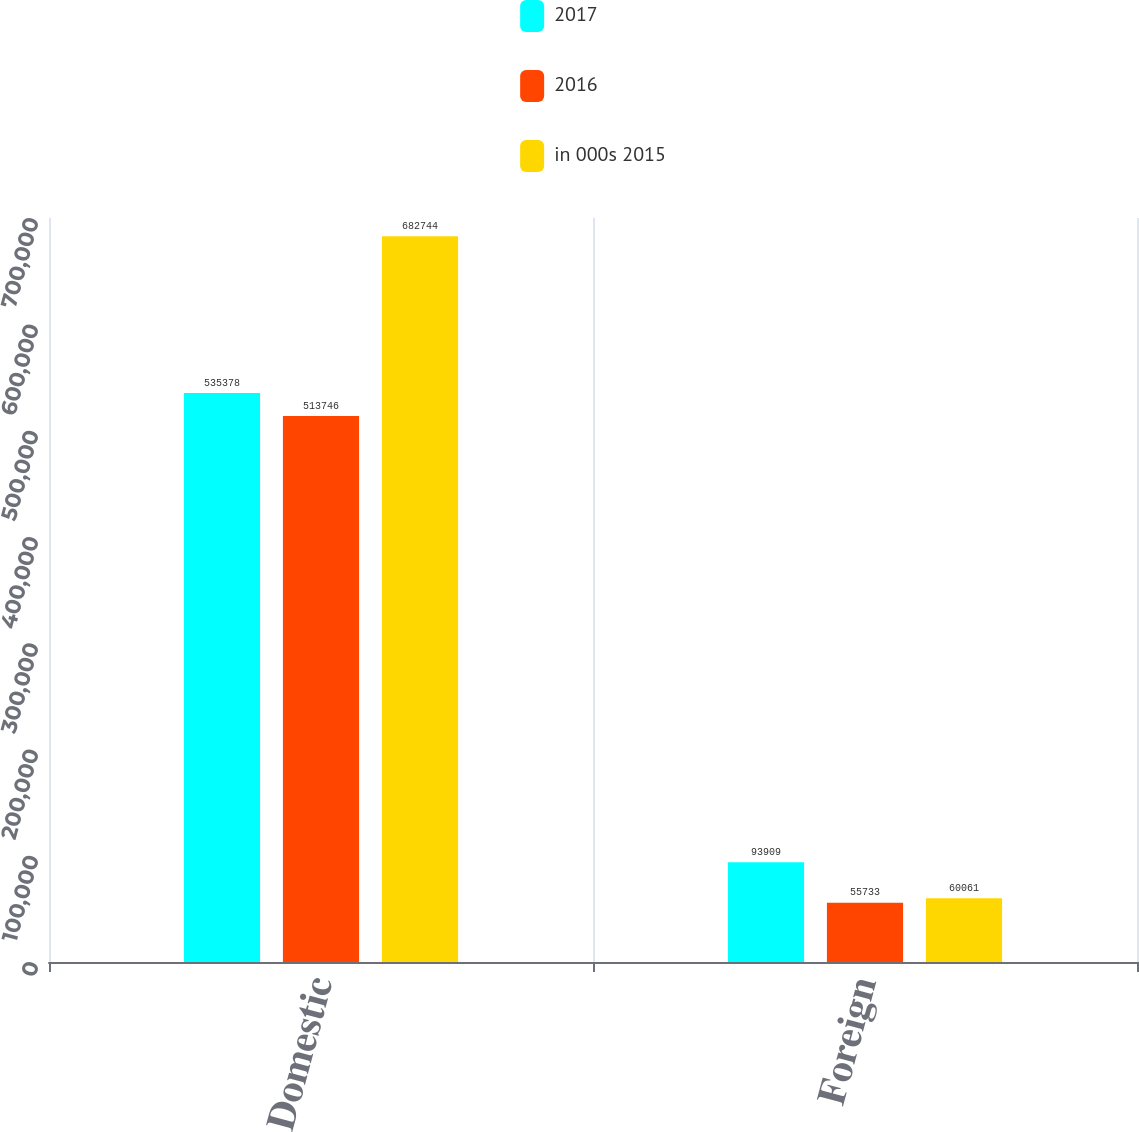Convert chart. <chart><loc_0><loc_0><loc_500><loc_500><stacked_bar_chart><ecel><fcel>Domestic<fcel>Foreign<nl><fcel>2017<fcel>535378<fcel>93909<nl><fcel>2016<fcel>513746<fcel>55733<nl><fcel>in 000s 2015<fcel>682744<fcel>60061<nl></chart> 